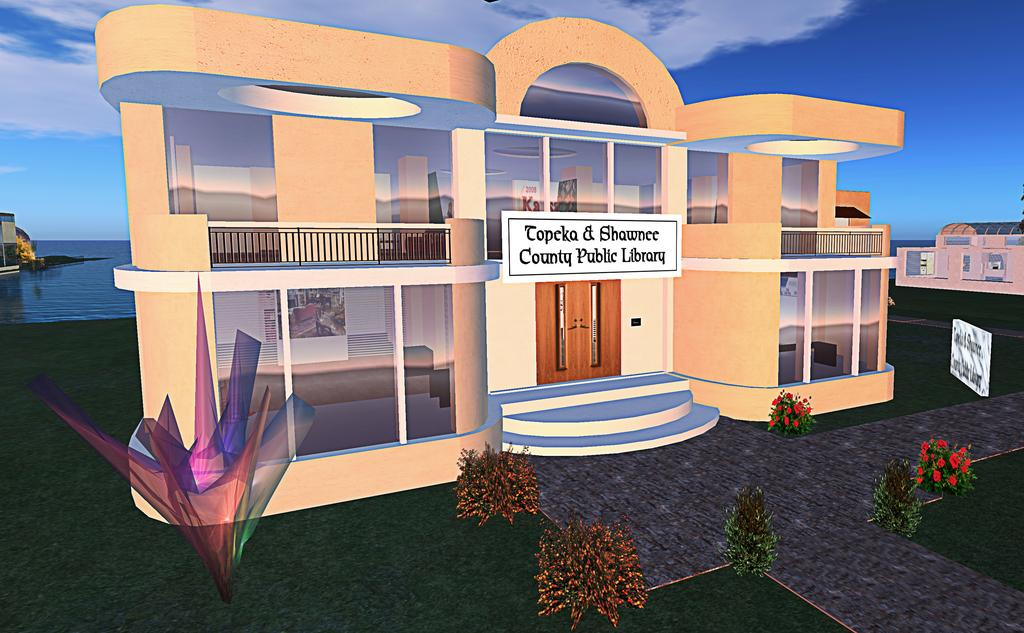What type of visual content is depicted in the image? The image is an animation. What type of structures can be seen in the image? There are buildings in the image. What type of vegetation is present in the image? There are bushes in the image. What objects are present in the image that might be used for displaying information or advertisements? There are boards in the image. What natural elements can be seen in the background of the image? There is water and the sky visible in the background of the image. How many people are sleeping on the boards in the image? There are no people sleeping on the boards in the image; the boards are used for displaying information or advertisements. What type of furniture is present in the image for storing items? There is no furniture present in the image for storing items, such as a drawer. 